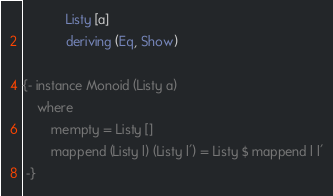<code> <loc_0><loc_0><loc_500><loc_500><_Haskell_>            Listy [a]
            deriving (Eq, Show)

{- instance Monoid (Listy a)
    where
        mempty = Listy []
        mappend (Listy l) (Listy l') = Listy $ mappend l l'
 -}</code> 